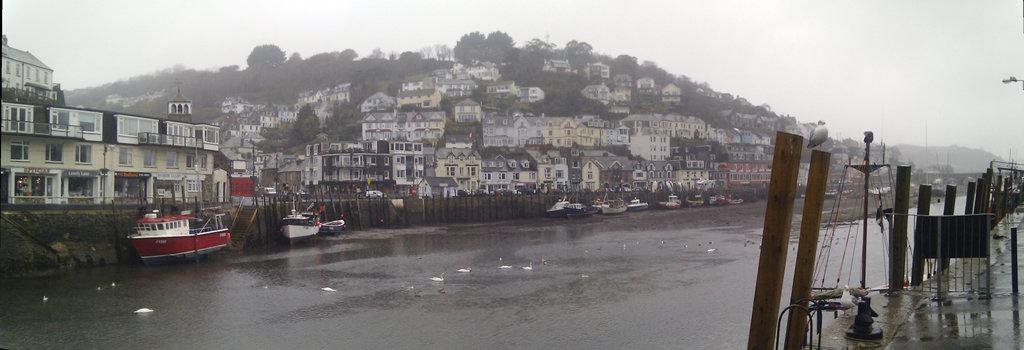What type of vehicles can be seen in the image? There are boats in the image. What animals are present on the water's surface? There are ducks on the surface of the water. What natural element is visible in the image? There is water visible in the image. What structures can be seen in the background of the image? There are houses and trees in the background of the image. What part of the natural environment is visible in the image? The sky is visible in the image. Where is the shelf located in the image? There is no shelf present in the image. What type of grass can be seen growing near the water? There is no grass visible in the image; it only features boats, ducks, water, houses, trees, and the sky. 